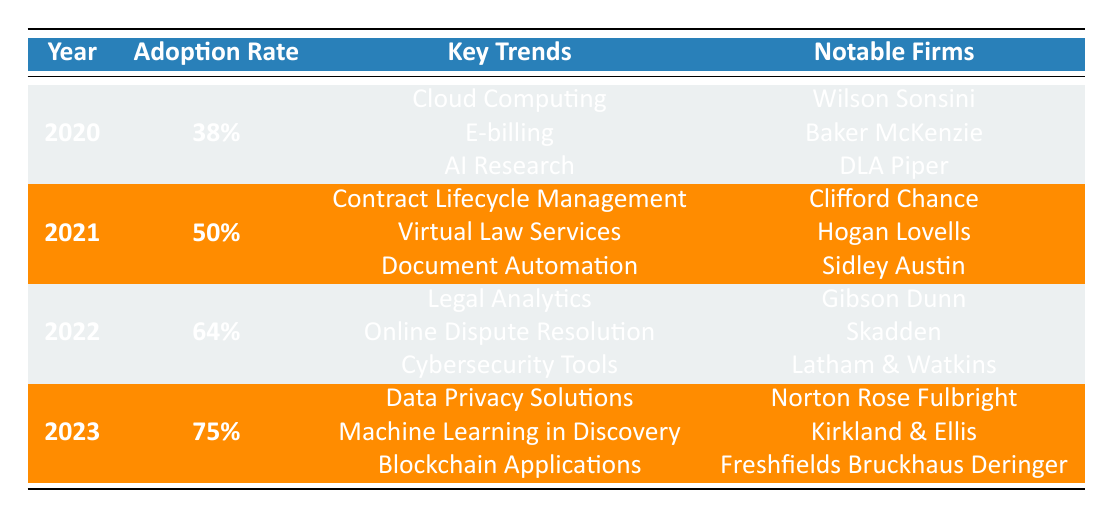What was the adoption rate for legal technology in 2021? The table shows that the adoption rate in 2021 is specifically listed as 50%.
Answer: 50% Which notable firm adopted legal technology in 2020? The table lists "Wilson Sonsini," "Baker McKenzie," and "DLA Piper" as notable firms for the year 2020.
Answer: Wilson Sonsini, Baker McKenzie, DLA Piper What were the key trends in legal technology adoption in 2022? According to the table, the key trends in 2022 included "Legal Analytics," "Online Dispute Resolution," and "Cybersecurity Tools."
Answer: Legal Analytics, Online Dispute Resolution, Cybersecurity Tools Is "Virtual Law Services" a key trend in 2020? The table indicates that "Virtual Law Services" is listed as a key trend only for 2021 and not for 2020.
Answer: No What is the difference in the adoption rates between 2020 and 2023? The adoption rate in 2020 is 38% and in 2023 is 75%. To find the difference: 75% - 38% = 37%.
Answer: 37% How many law firms are listed as notable firms for 2021? The notable firms for 2021 are "Clifford Chance," "Hogan Lovells," and "Sidley Austin," which totals to 3 firms.
Answer: 3 What trend appears in both 2021 and 2022? The trend related to "Document Automation" appears in 2021, while "Cybersecurity Tools" appears in 2022. There are no shared trends.
Answer: None If you combine the adoption rates of 2020 and 2021, what is the total adoption rate? The adoption rates are 38% for 2020 and 50% for 2021. Adding them gives 38% + 50% = 88%.
Answer: 88% Which notable firm had the highest legal tech adoption rate in 2022? The notable firms listed for 2022 include "Gibson Dunn," "Skadden," and "Latham & Watkins," but the table does not provide a way to rank them based on adoption rates. Each firm adopted tech strategies equally as per the year's rate of 64%.
Answer: Not ranked What is the trend for 2023 related to AI? The key trend for 2023 includes "Machine Learning in Discovery," which relates to AI applications in legal contexts.
Answer: Machine Learning in Discovery 